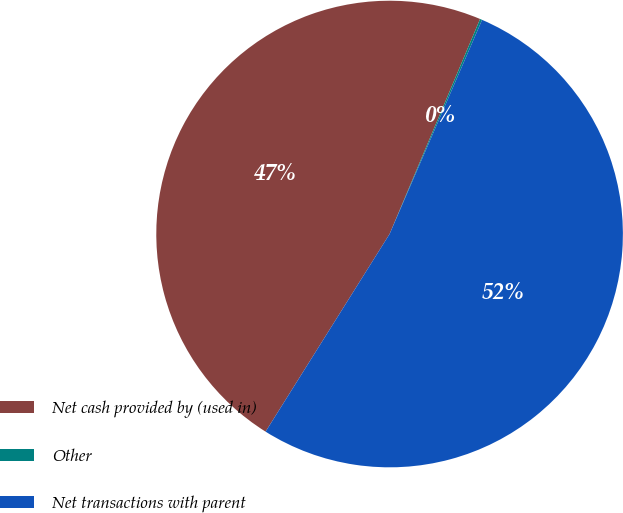Convert chart. <chart><loc_0><loc_0><loc_500><loc_500><pie_chart><fcel>Net cash provided by (used in)<fcel>Other<fcel>Net transactions with parent<nl><fcel>47.42%<fcel>0.15%<fcel>52.43%<nl></chart> 